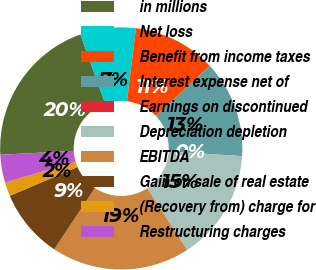Convert chart. <chart><loc_0><loc_0><loc_500><loc_500><pie_chart><fcel>in millions<fcel>Net loss<fcel>Benefit from income taxes<fcel>Interest expense net of<fcel>Earnings on discontinued<fcel>Depreciation depletion<fcel>EBITDA<fcel>Gain on sale of real estate<fcel>(Recovery from) charge for<fcel>Restructuring charges<nl><fcel>20.36%<fcel>7.41%<fcel>11.11%<fcel>12.96%<fcel>0.01%<fcel>14.81%<fcel>18.51%<fcel>9.26%<fcel>1.86%<fcel>3.71%<nl></chart> 